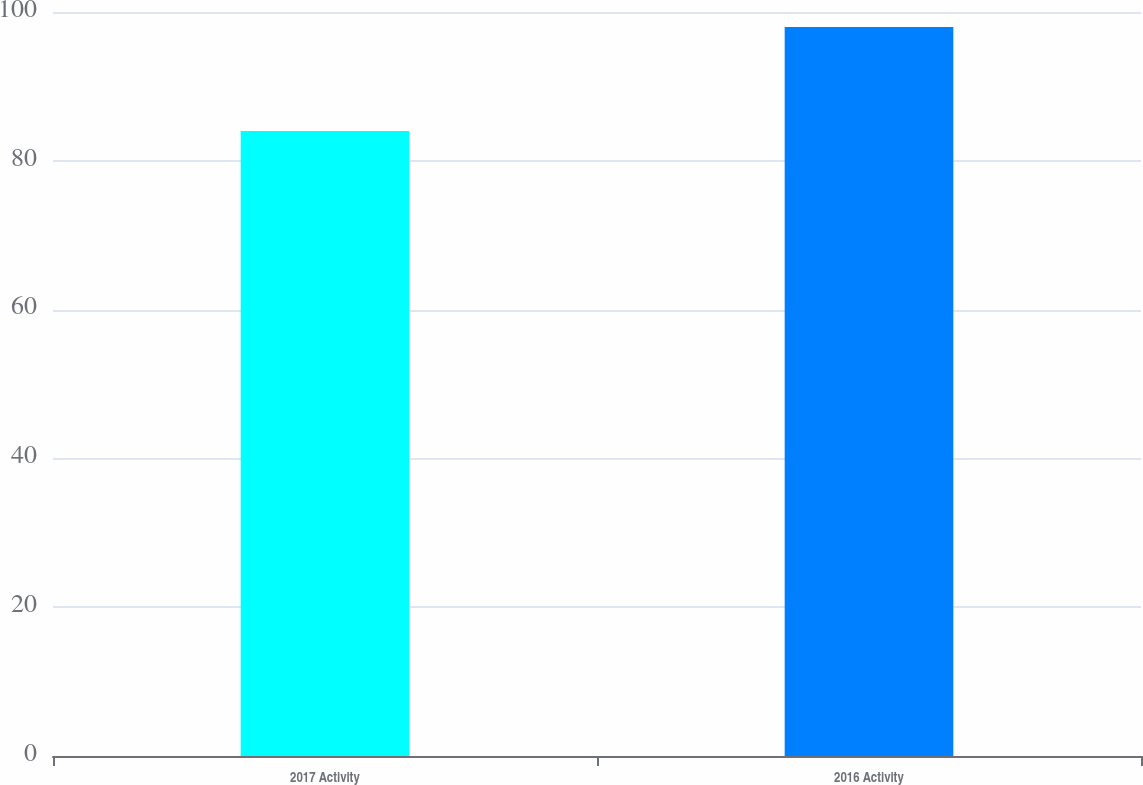Convert chart. <chart><loc_0><loc_0><loc_500><loc_500><bar_chart><fcel>2017 Activity<fcel>2016 Activity<nl><fcel>84<fcel>98<nl></chart> 